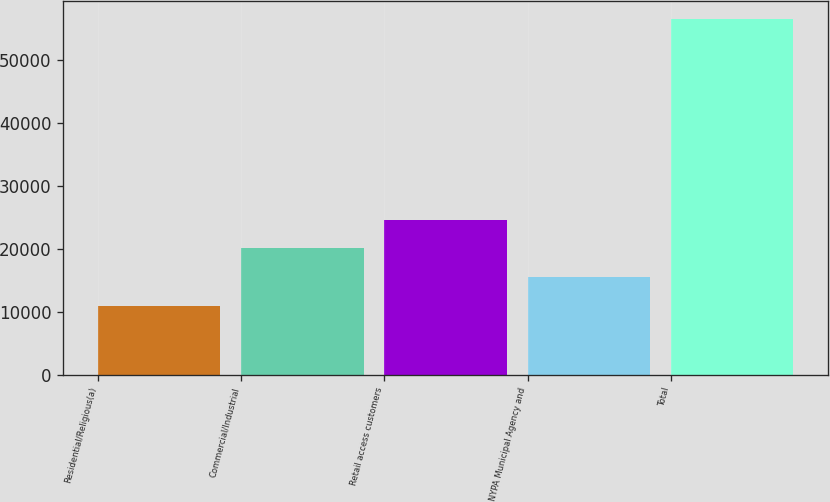<chart> <loc_0><loc_0><loc_500><loc_500><bar_chart><fcel>Residential/Religious(a)<fcel>Commercial/Industrial<fcel>Retail access customers<fcel>NYPA Municipal Agency and<fcel>Total<nl><fcel>10952<fcel>20095<fcel>24666.5<fcel>15523.5<fcel>56667<nl></chart> 